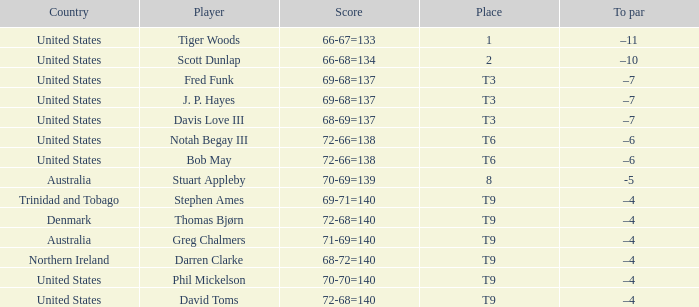What is the To par value that goes with a Score of 70-69=139? -5.0. 